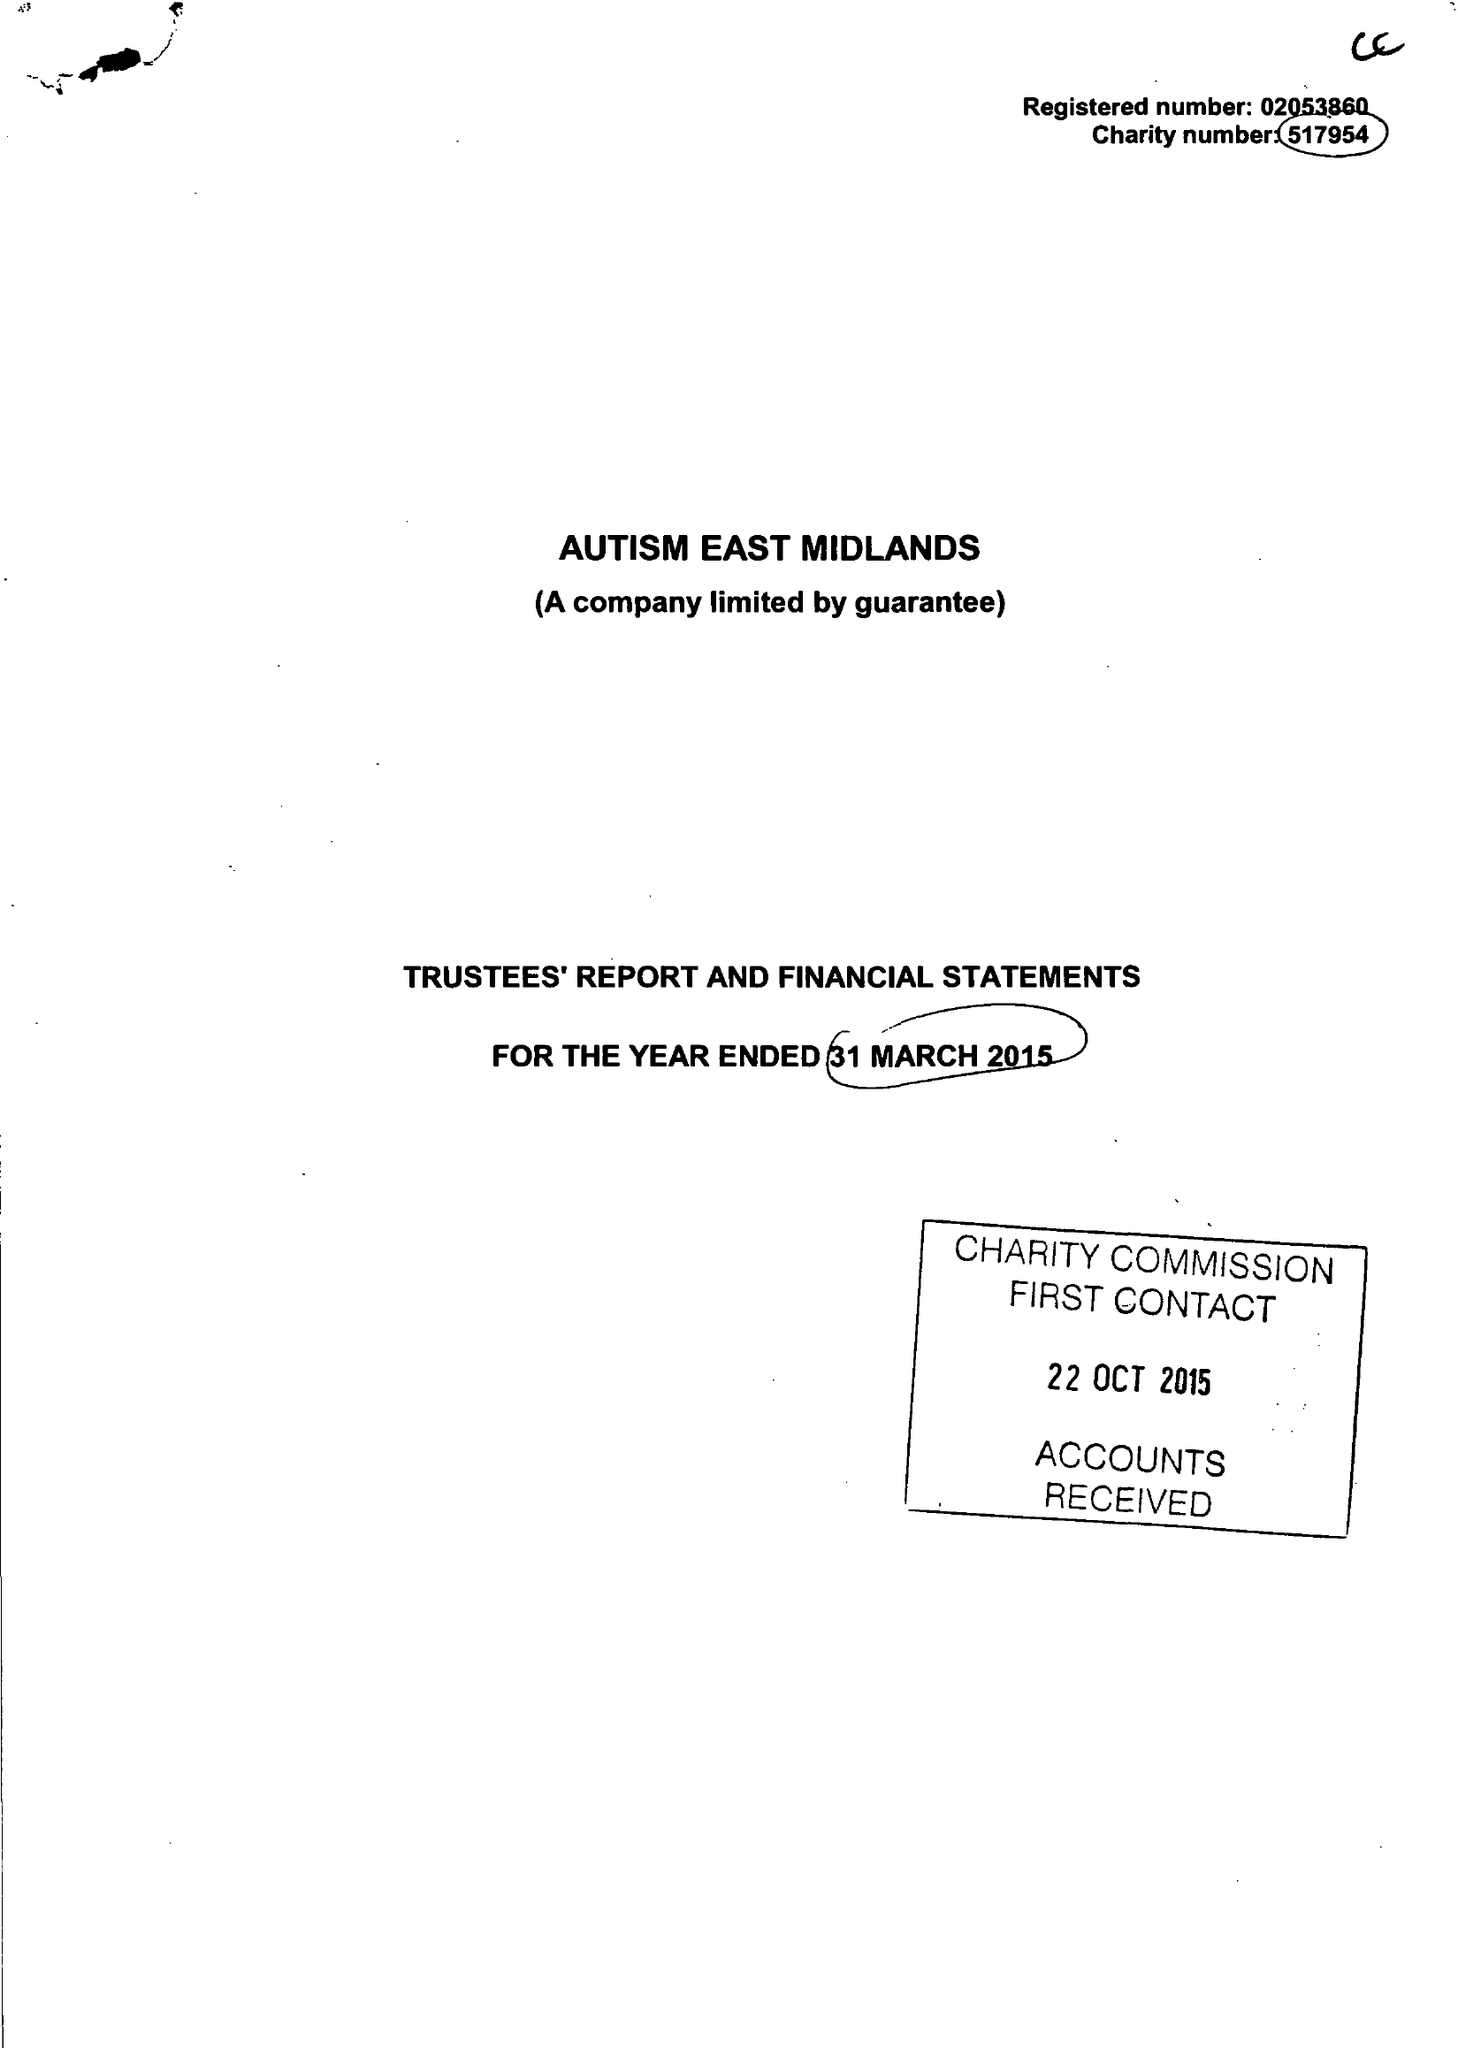What is the value for the charity_name?
Answer the question using a single word or phrase. Autism East Midlands 